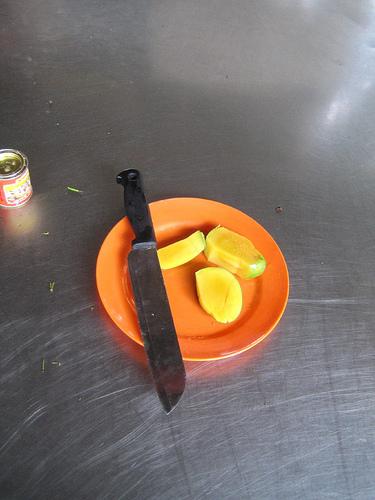What color is the plate?
Be succinct. Orange. What type of surface is the plate sitting on?
Write a very short answer. Metal. Has this knife been used?
Keep it brief. Yes. 